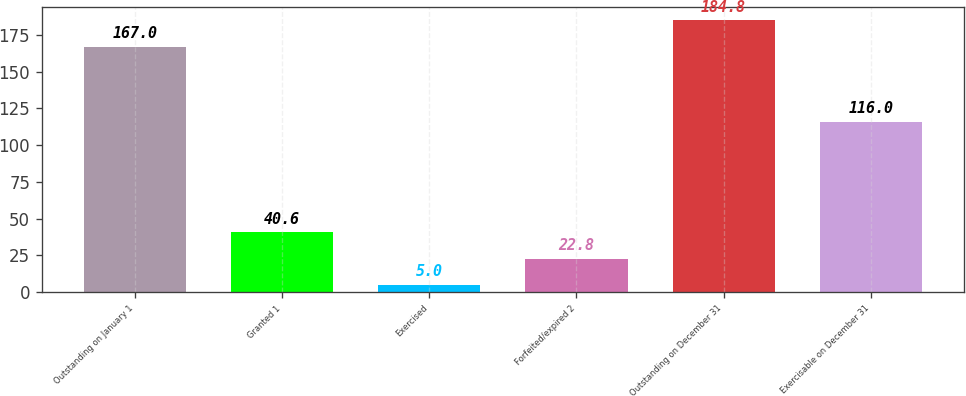<chart> <loc_0><loc_0><loc_500><loc_500><bar_chart><fcel>Outstanding on January 1<fcel>Granted 1<fcel>Exercised<fcel>Forfeited/expired 2<fcel>Outstanding on December 31<fcel>Exercisable on December 31<nl><fcel>167<fcel>40.6<fcel>5<fcel>22.8<fcel>184.8<fcel>116<nl></chart> 